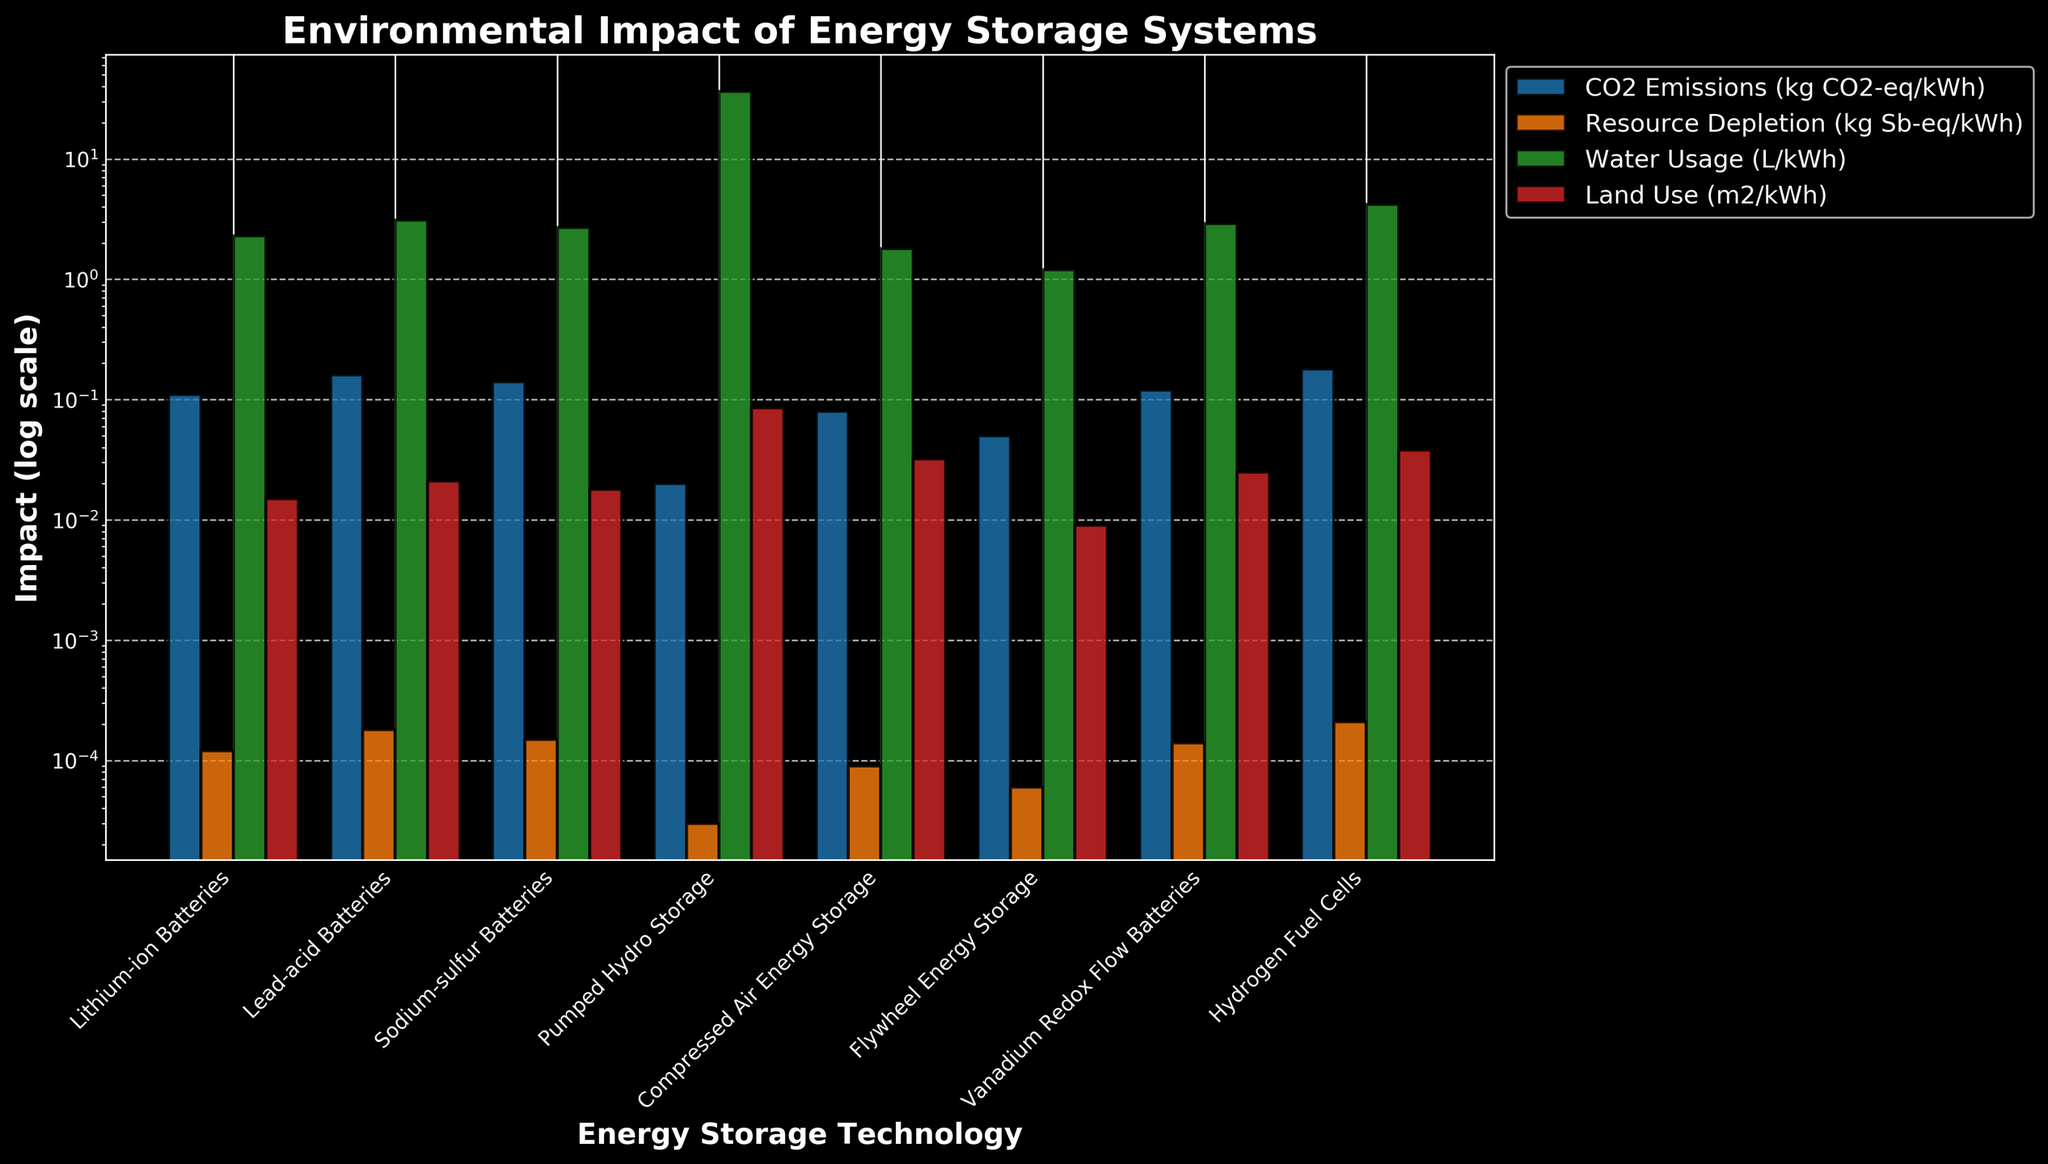Which technology has the highest CO2 emissions per kWh? The figure lists CO2 emissions for each technology and the highest value is seen in Hydrogen Fuel Cells.
Answer: Hydrogen Fuel Cells Which technology has the lowest land use per kWh? The bar showing land use for Flywheel Energy Storage is the shortest among all technologies.
Answer: Flywheel Energy Storage What is the difference in water usage per kWh between Pumped Hydro Storage and Lithium-ion Batteries? The water usage is 36.5 L/kWh for Pumped Hydro Storage and 2.3 L/kWh for Lithium-ion Batteries, subtracting gives (36.5 - 2.3) = 34.2 L/kWh.
Answer: 34.2 L/kWh Which technology has the lowest resource depletion? By comparing the heights of the bars representing resource depletion, Pumped Hydro Storage has the lowest value.
Answer: Pumped Hydro Storage Which technologies have CO2 emissions greater than 0.1 kg CO2-eq/kWh? By observing the heights of the bars exceeding 0.1 kg CO2-eq/kWh for CO2 emissions, we see Lead-acid Batteries, Sodium-sulfur Batteries, Vanadium Redox Flow Batteries, and Hydrogen Fuel Cells.
Answer: Lead-acid Batteries, Sodium-sulfur Batteries, Vanadium Redox Flow Batteries, Hydrogen Fuel Cells For which metric is the difference between the highest and lowest values the greatest? The bars representing water usage show the most significant variation, suggesting the difference is largest for water usage.
Answer: Water Usage Compare the land use per kWh of Compressed Air Energy Storage to Vanadium Redox Flow Batteries. Which one is greater? The bar for Vanadium Redox Flow Batteries is shorter than that for Compressed Air Energy Storage in the land use category.
Answer: Compressed Air Energy Storage What is the average CO2 emissions of Lithium-ion, Lead-acid, and Sodium-sulfur Batteries? Summing the CO2 emissions (0.11 + 0.16 + 0.14) gives 0.41. The average is 0.41/3 = 0.137 kg CO2-eq/kWh.
Answer: 0.137 kg CO2-eq/kWh 